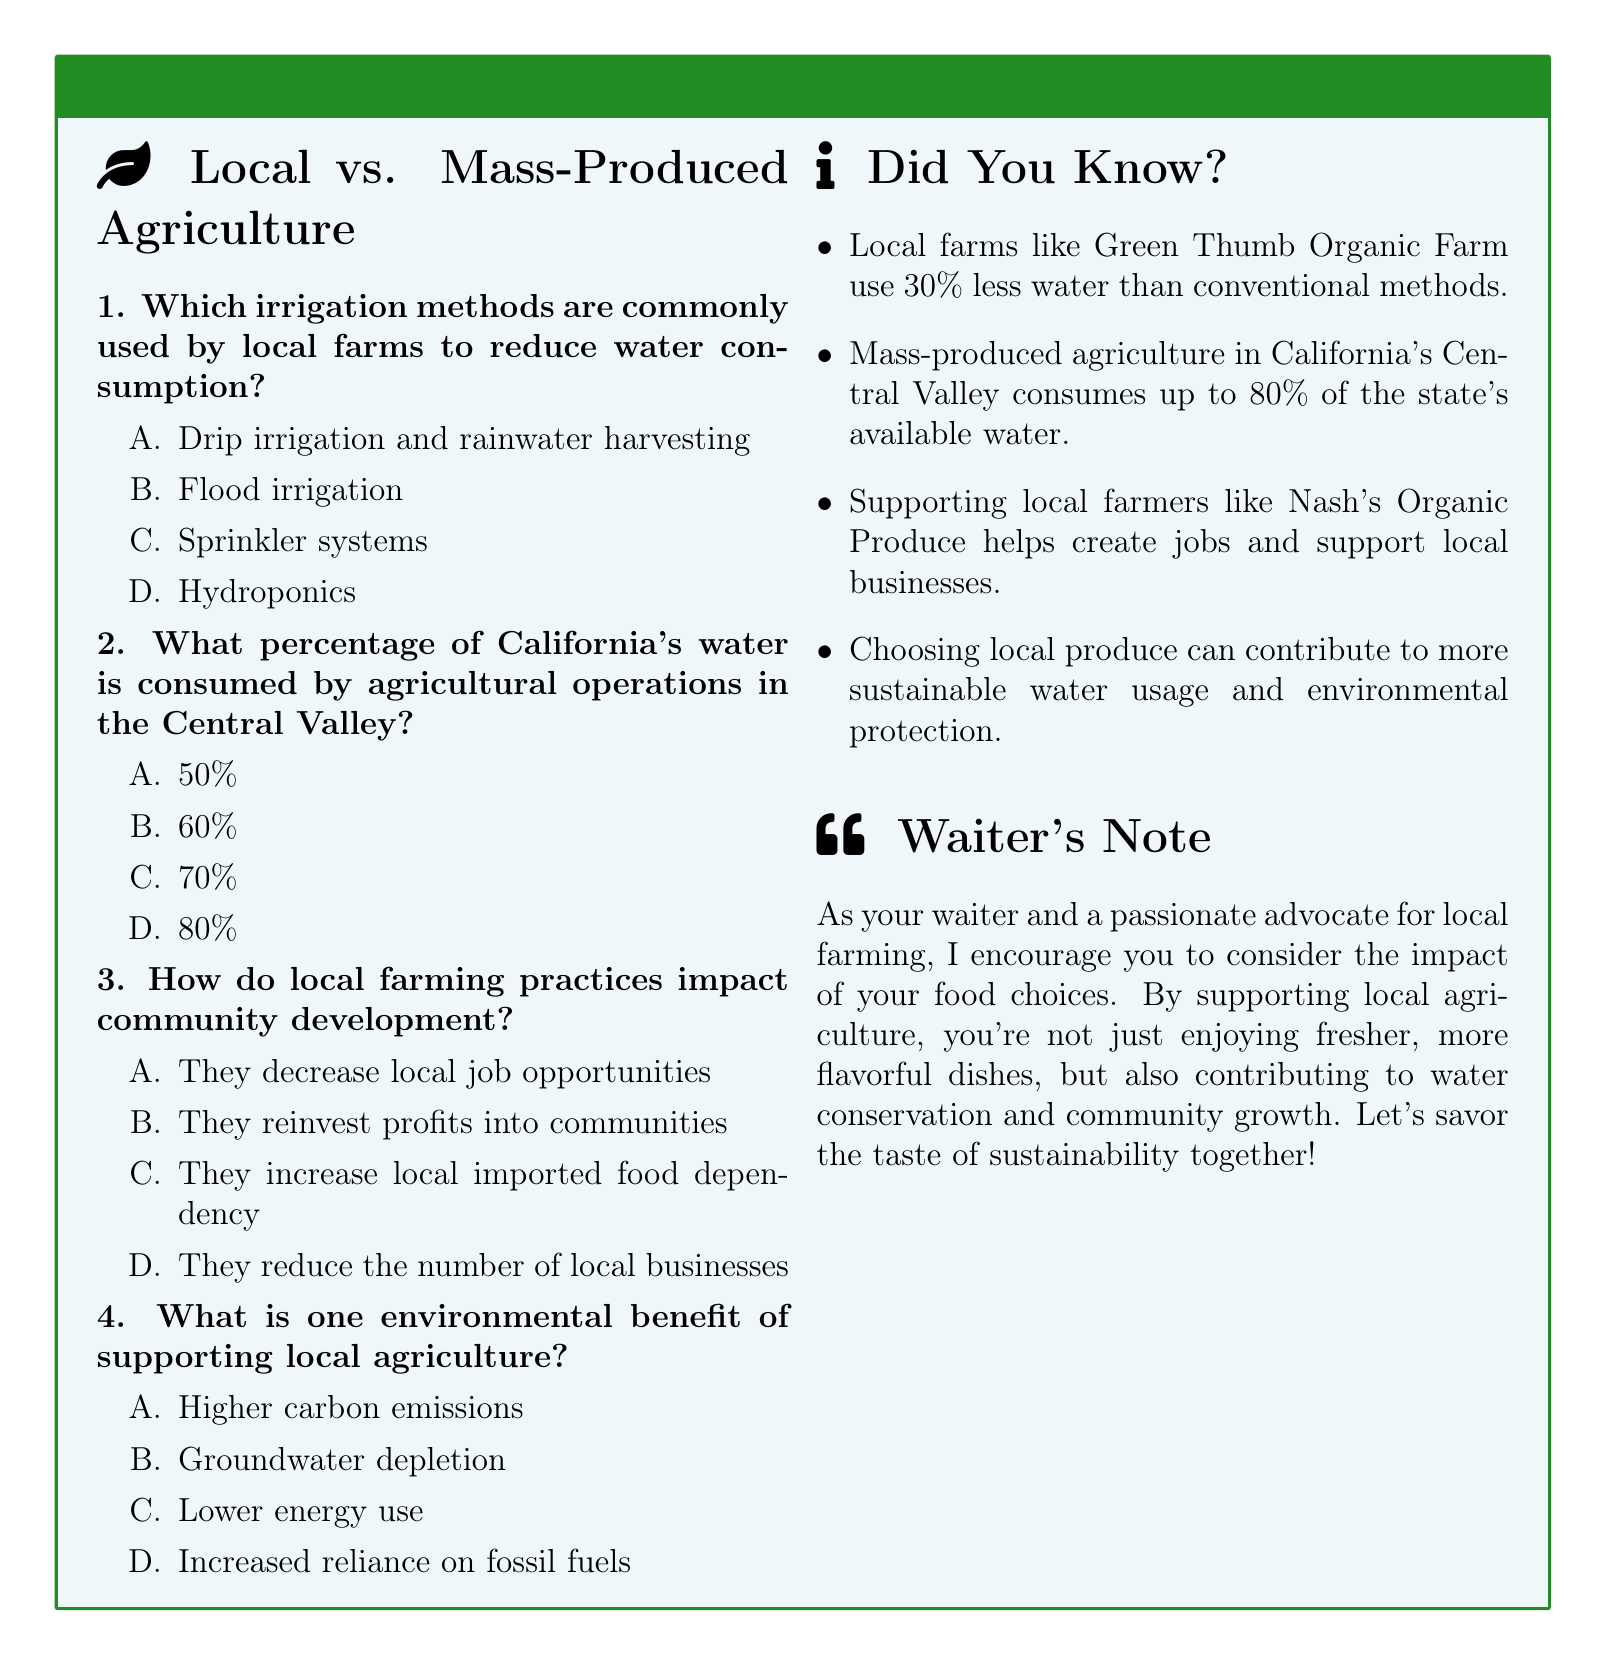What irrigation methods are used by local farms? The document states that local farms often use drip irrigation and rainwater harvesting to reduce water consumption.
Answer: Drip irrigation and rainwater harvesting What percentage of California's water is used by the Central Valley? According to the document, mass-produced agriculture in California's Central Valley consumes up to 80% of the state's available water.
Answer: 80% How do local farming practices affect community development? The document indicates that local farming practices reinvest profits into communities, supporting local development.
Answer: They reinvest profits into communities What is one environmental benefit of supporting local agriculture? The document highlights that supporting local agriculture results in lower energy use, which is a benefit for the environment.
Answer: Lower energy use What is the water savings statistic for local farms compared to conventional methods? The document mentions that local farms like Green Thumb Organic Farm use 30% less water than conventional methods.
Answer: 30% less water 